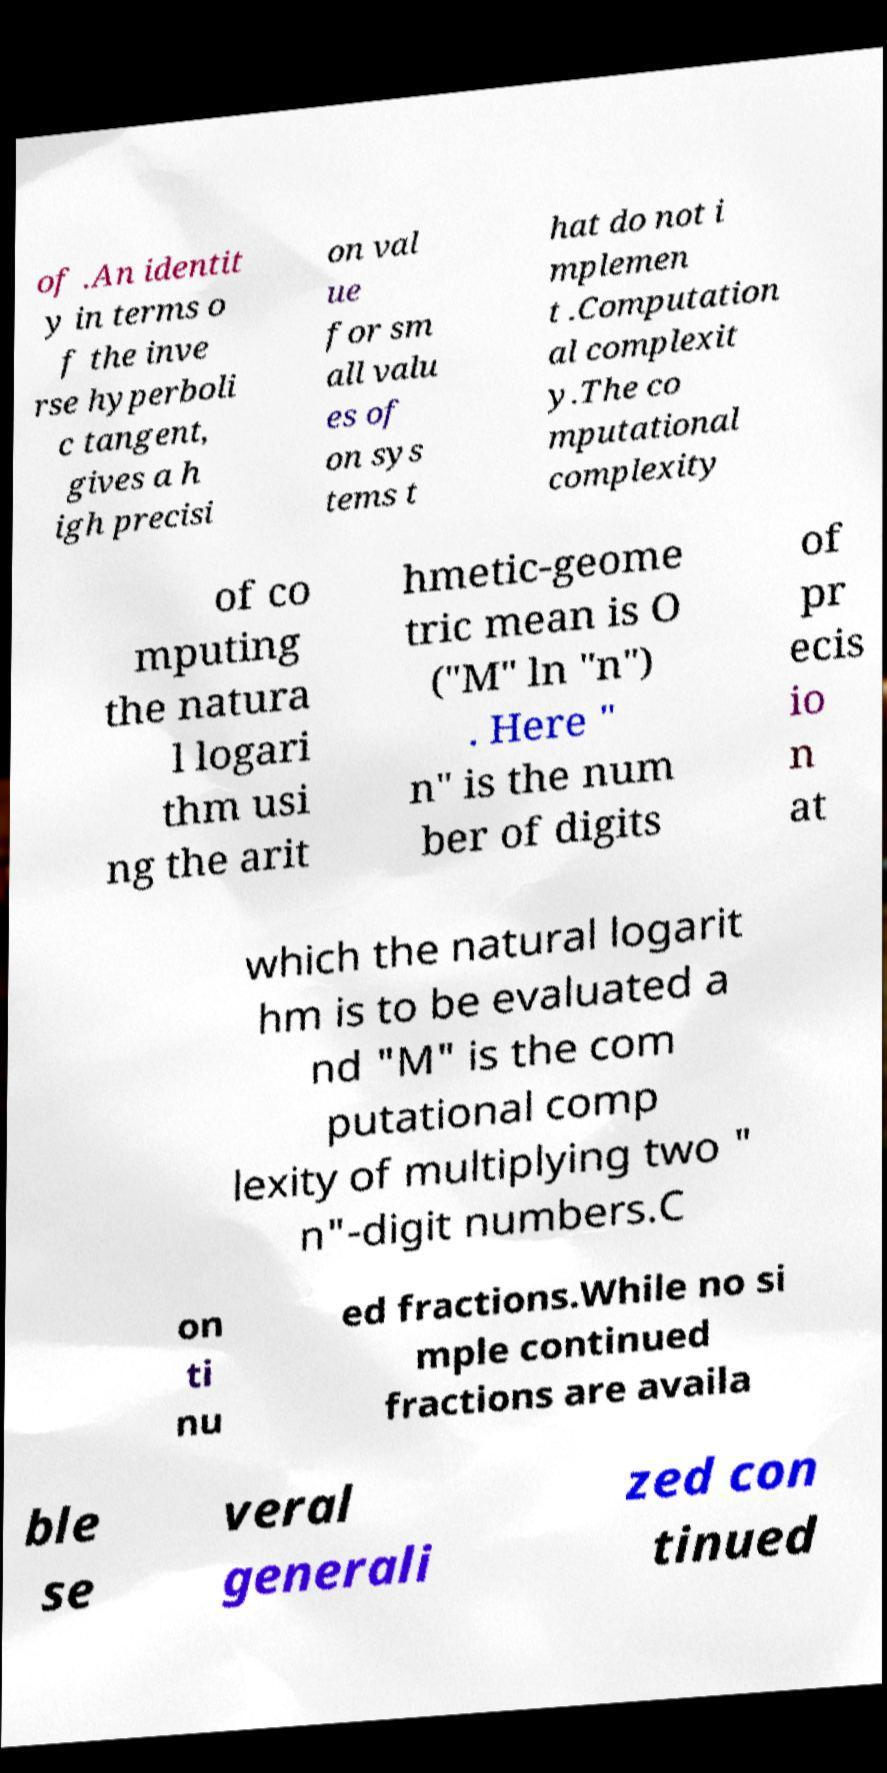Could you assist in decoding the text presented in this image and type it out clearly? of .An identit y in terms o f the inve rse hyperboli c tangent, gives a h igh precisi on val ue for sm all valu es of on sys tems t hat do not i mplemen t .Computation al complexit y.The co mputational complexity of co mputing the natura l logari thm usi ng the arit hmetic-geome tric mean is O ("M" ln "n") . Here " n" is the num ber of digits of pr ecis io n at which the natural logarit hm is to be evaluated a nd "M" is the com putational comp lexity of multiplying two " n"-digit numbers.C on ti nu ed fractions.While no si mple continued fractions are availa ble se veral generali zed con tinued 